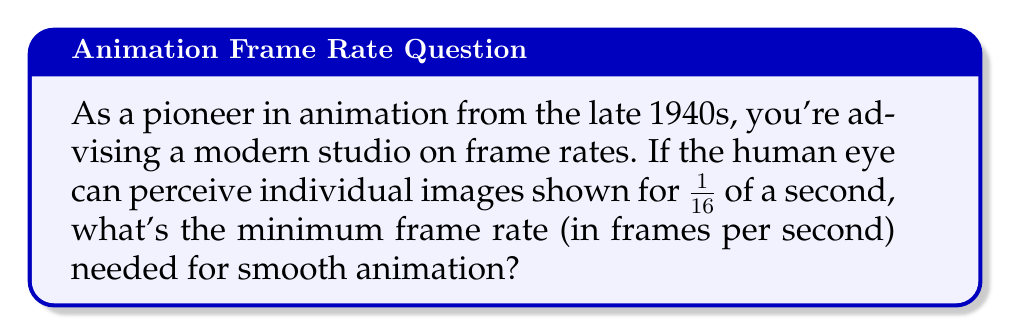Could you help me with this problem? To calculate the minimum frame rate needed for smooth animation, we need to consider the persistence of vision and the rate at which the human eye can perceive individual images.

Step 1: Understand the given information
- The human eye can perceive individual images shown for 1/16th of a second.

Step 2: Convert the perception time to a frequency
The frequency (frames per second) is the inverse of the time for one frame.

$$ \text{Frame rate} = \frac{1}{\text{Time per frame}} $$

Step 3: Calculate the frame rate
$$ \text{Frame rate} = \frac{1}{1/16} = 16 \text{ frames per second} $$

Step 4: Interpret the result
This calculated rate of 16 frames per second is the theoretical minimum for the images to appear as a continuous motion rather than individual frames. However, in practice, a higher frame rate is often used to ensure smoother animation and to account for variations in human perception.

In the early days of animation, a standard of 24 frames per second was established for motion picture film, which is still commonly used today. Some modern digital animations use even higher frame rates, such as 30, 60, or even 120 frames per second for ultra-smooth motion.
Answer: 16 frames per second 